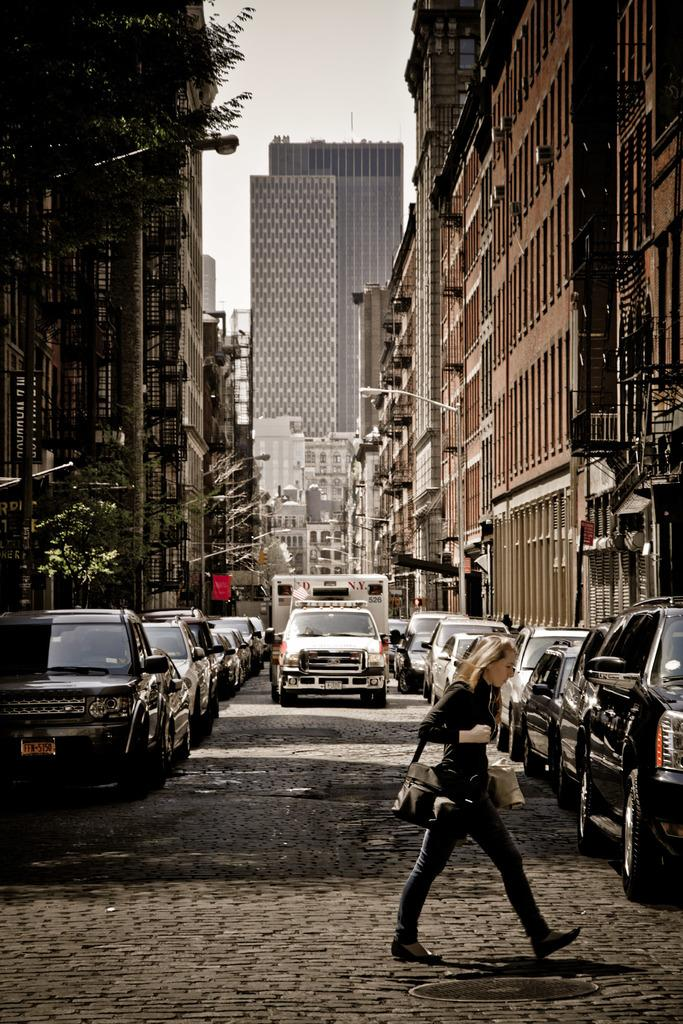<image>
Render a clear and concise summary of the photo. A girl is crossing a street and an ambulance is coming toward her that says N.Y. 